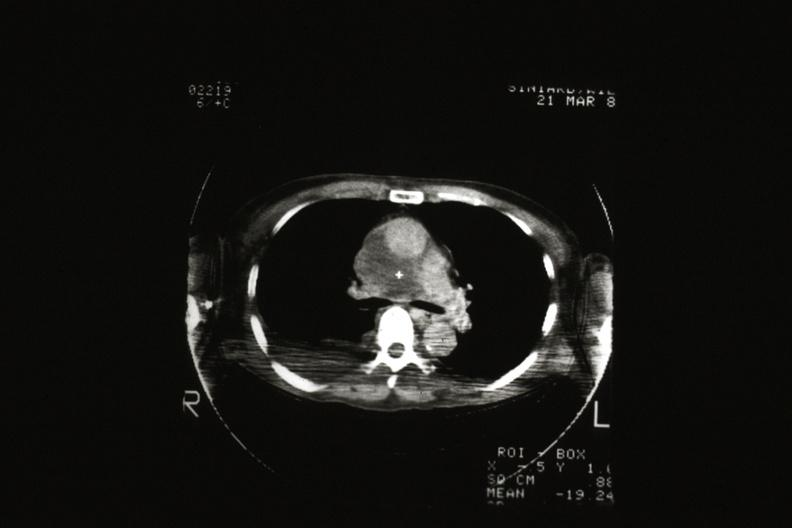s amebiasis present?
Answer the question using a single word or phrase. No 